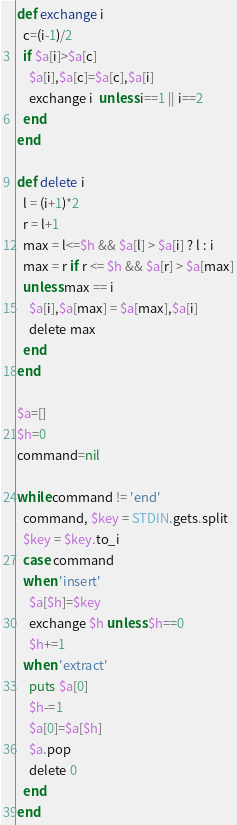<code> <loc_0><loc_0><loc_500><loc_500><_Ruby_>def exchange i
  c=(i-1)/2
  if $a[i]>$a[c]
    $a[i],$a[c]=$a[c],$a[i]
    exchange i  unless i==1 || i==2
  end
end

def delete i
  l = (i+1)*2
  r = l+1
  max = l<=$h && $a[l] > $a[i] ? l : i
  max = r if r <= $h && $a[r] > $a[max]
  unless max == i
    $a[i],$a[max] = $a[max],$a[i]
    delete max
  end
end

$a=[]
$h=0
command=nil

while command != 'end'
  command, $key = STDIN.gets.split
  $key = $key.to_i
  case command
  when 'insert'
    $a[$h]=$key
    exchange $h unless $h==0
    $h+=1
  when 'extract'
    puts $a[0]
    $h-=1
    $a[0]=$a[$h]
    $a.pop
    delete 0
  end
end</code> 